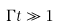<formula> <loc_0><loc_0><loc_500><loc_500>\Gamma t \gg 1</formula> 